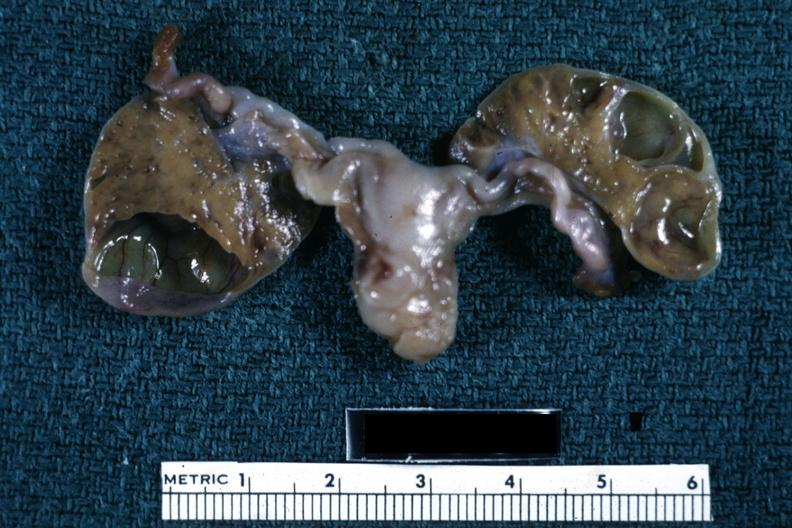s ovary present?
Answer the question using a single word or phrase. Yes 